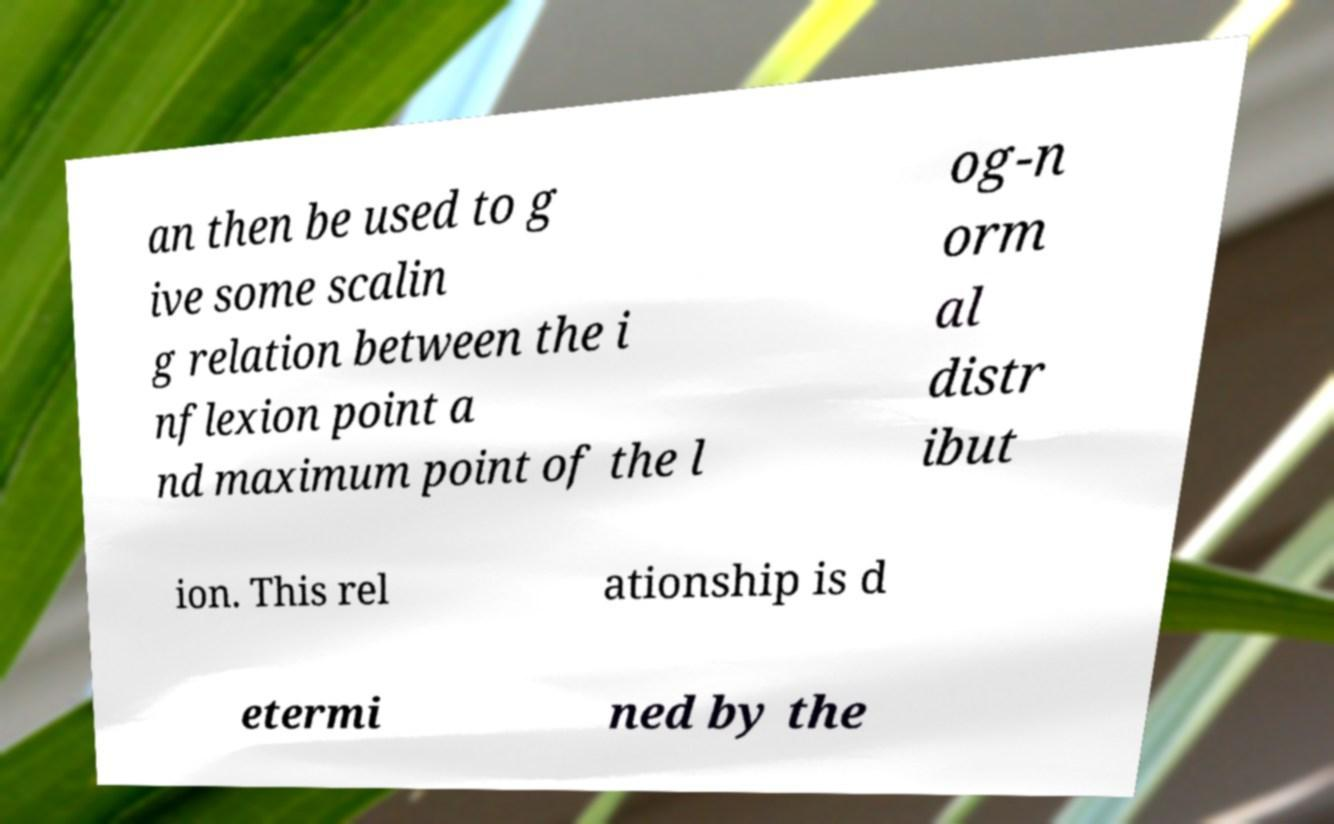Could you assist in decoding the text presented in this image and type it out clearly? an then be used to g ive some scalin g relation between the i nflexion point a nd maximum point of the l og-n orm al distr ibut ion. This rel ationship is d etermi ned by the 